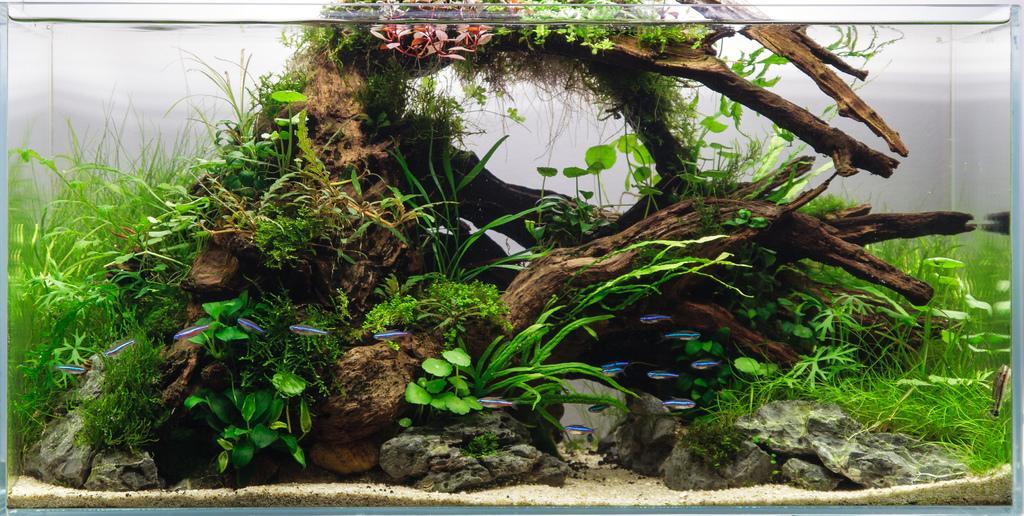Could you give a brief overview of what you see in this image? In this picture I can see the aquarium. In that I can see water, plants, grass, leaves and wooden structure. 